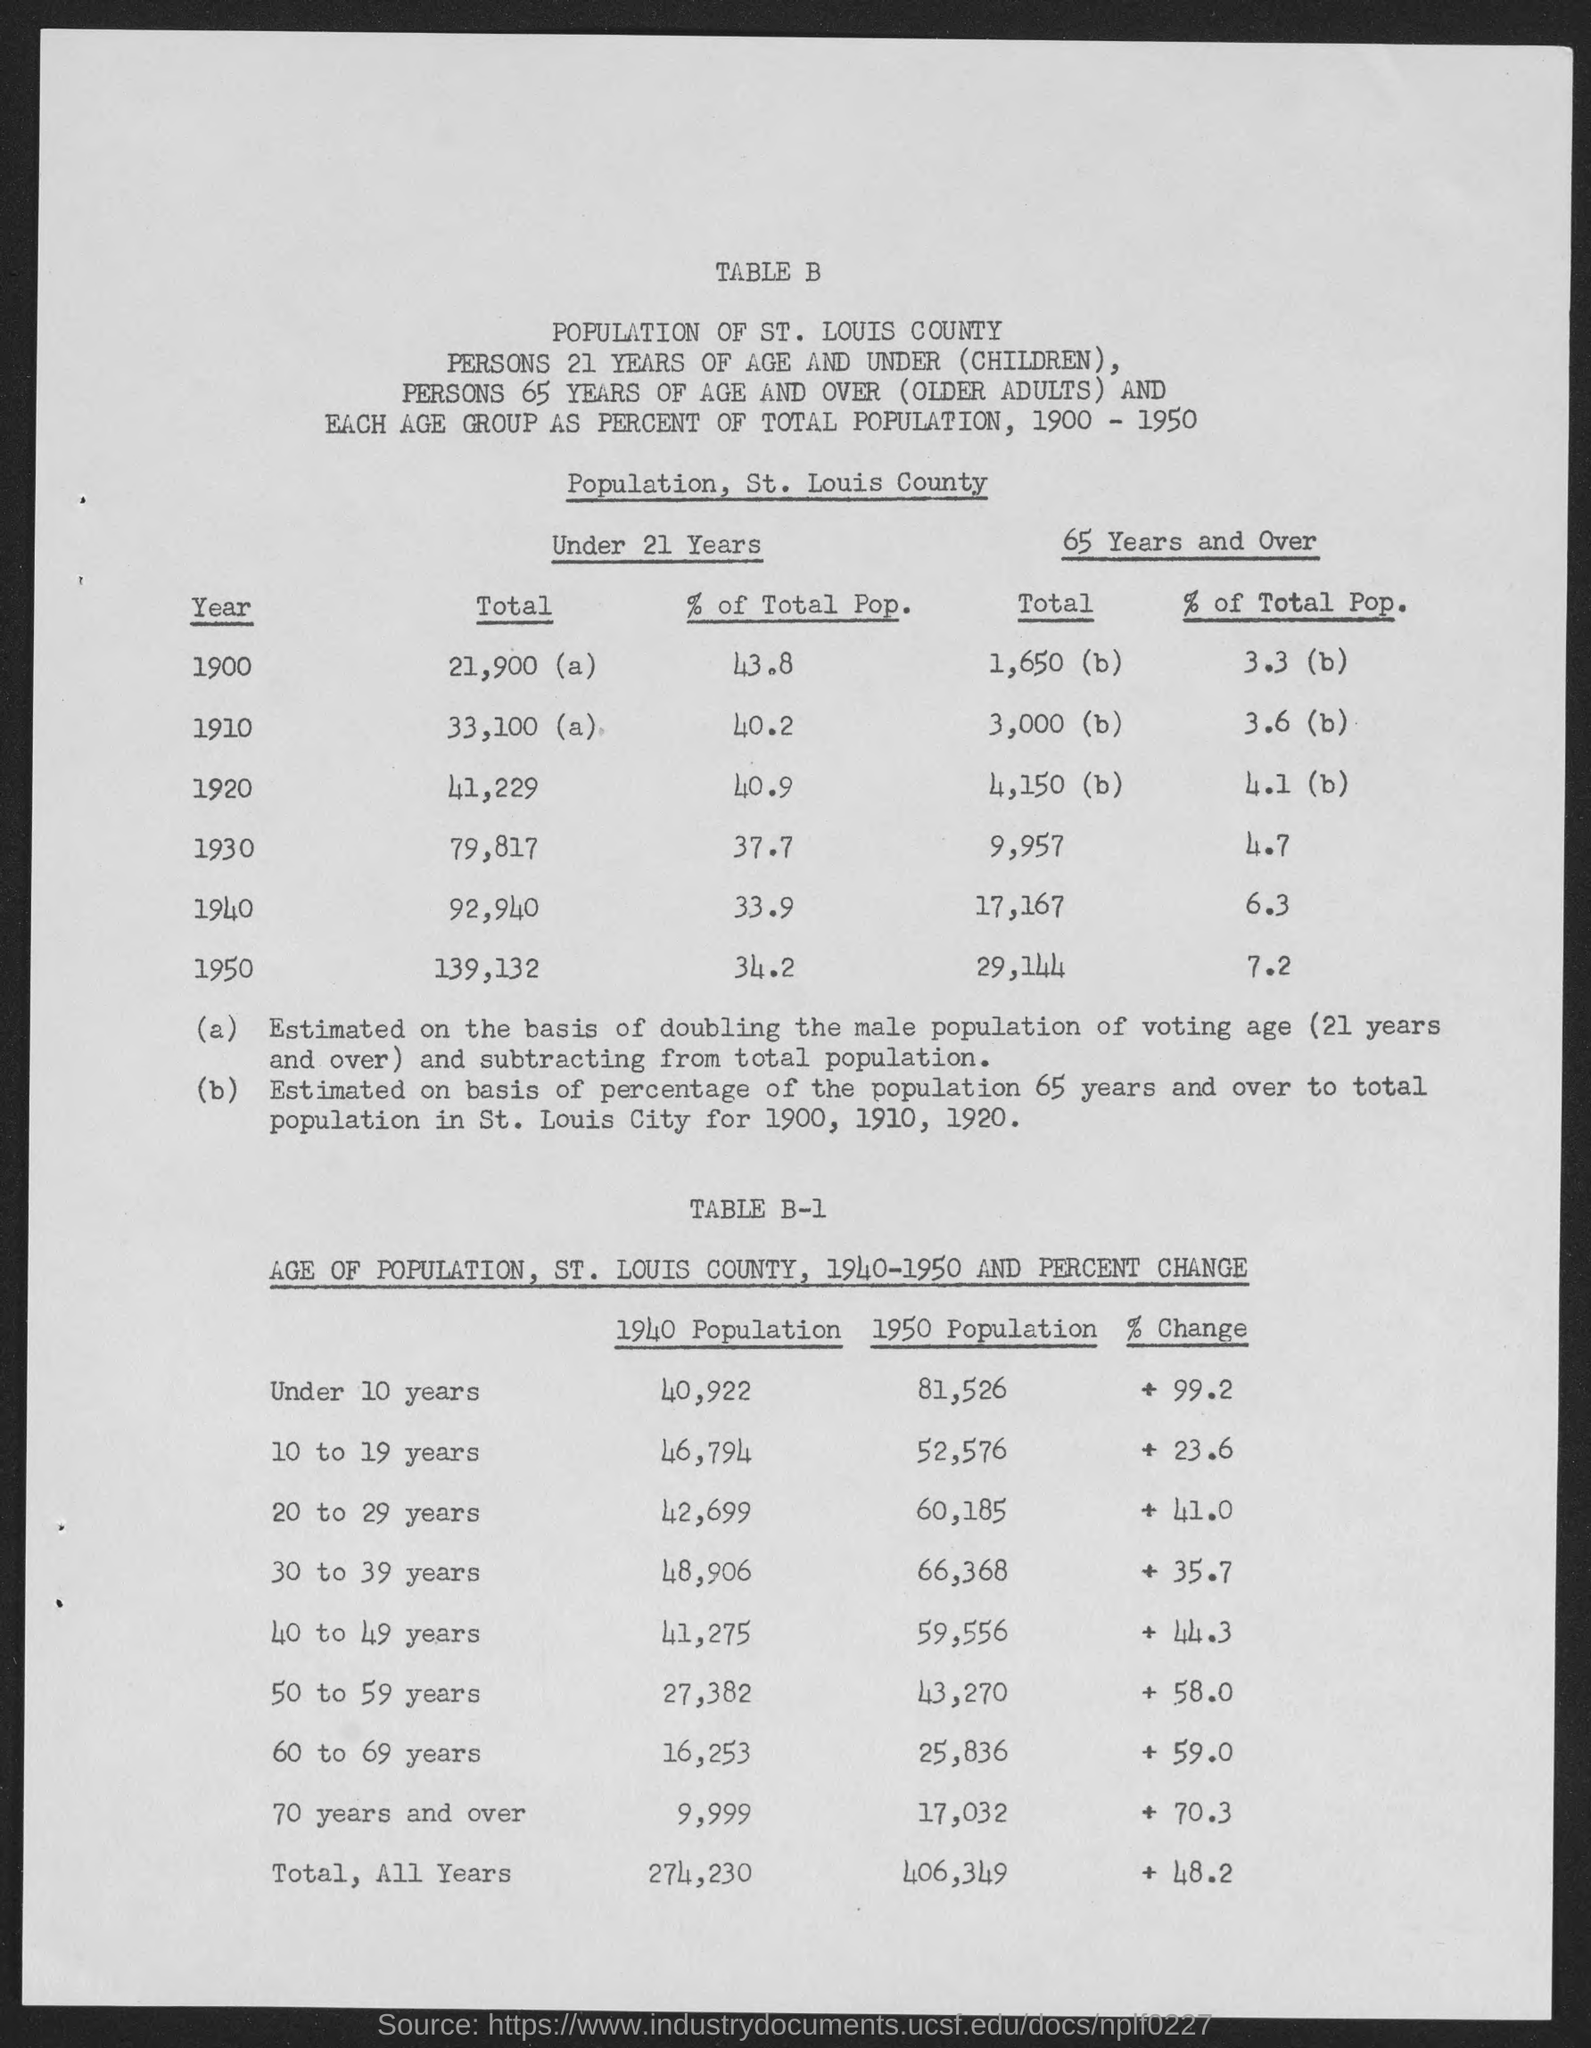Indicate a few pertinent items in this graphic. The total population under the age of 21 in 1950 was 139,132. In 1930, the total population under the age of 21 was 79,817. The total population under 21 years in 1900 was approximately 21,900. In the year 1920, the total population under the age of 21 was approximately 41,229. In 1940, the total population under the age of 21 was approximately 92,940. 